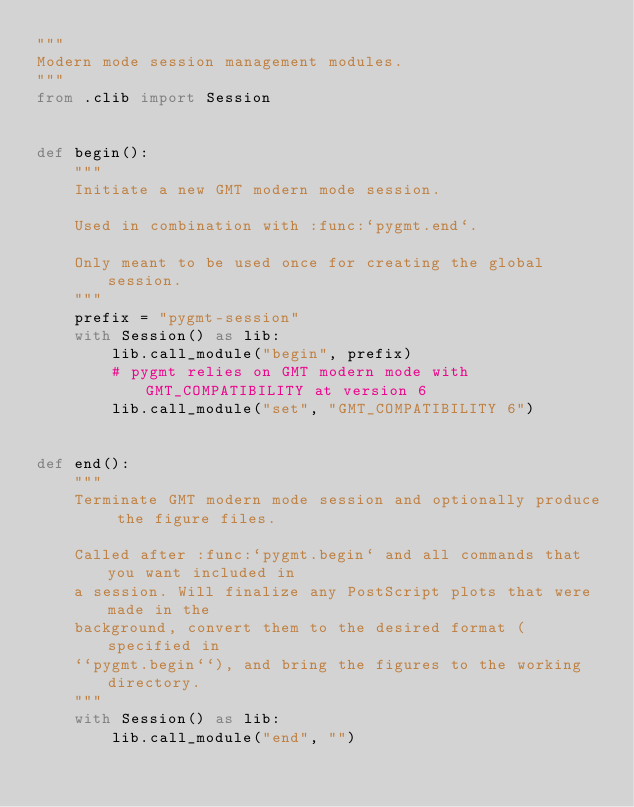<code> <loc_0><loc_0><loc_500><loc_500><_Python_>"""
Modern mode session management modules.
"""
from .clib import Session


def begin():
    """
    Initiate a new GMT modern mode session.

    Used in combination with :func:`pygmt.end`.

    Only meant to be used once for creating the global session.
    """
    prefix = "pygmt-session"
    with Session() as lib:
        lib.call_module("begin", prefix)
        # pygmt relies on GMT modern mode with GMT_COMPATIBILITY at version 6
        lib.call_module("set", "GMT_COMPATIBILITY 6")


def end():
    """
    Terminate GMT modern mode session and optionally produce the figure files.

    Called after :func:`pygmt.begin` and all commands that you want included in
    a session. Will finalize any PostScript plots that were made in the
    background, convert them to the desired format (specified in
    ``pygmt.begin``), and bring the figures to the working directory.
    """
    with Session() as lib:
        lib.call_module("end", "")
</code> 